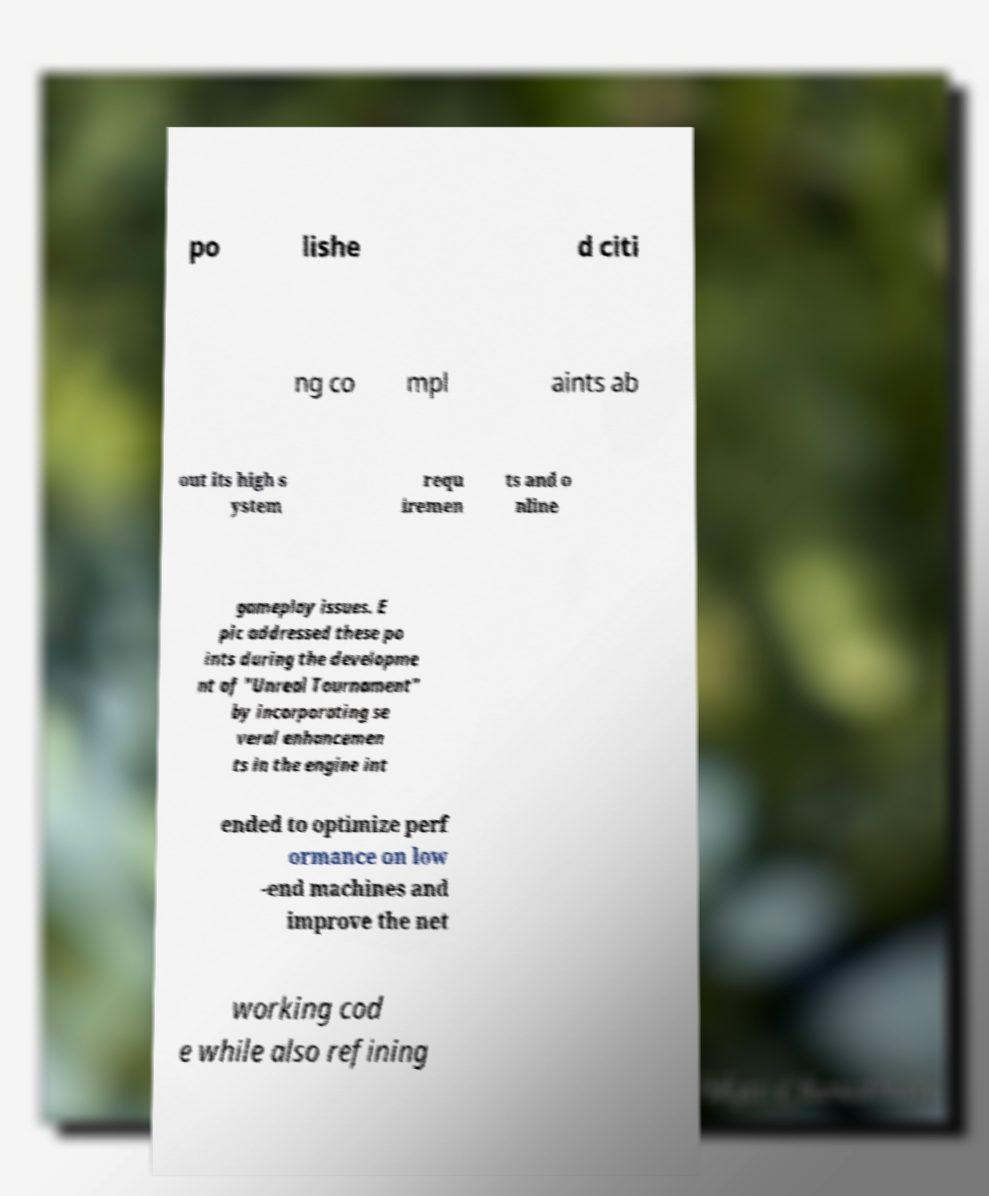Could you assist in decoding the text presented in this image and type it out clearly? po lishe d citi ng co mpl aints ab out its high s ystem requ iremen ts and o nline gameplay issues. E pic addressed these po ints during the developme nt of "Unreal Tournament" by incorporating se veral enhancemen ts in the engine int ended to optimize perf ormance on low -end machines and improve the net working cod e while also refining 